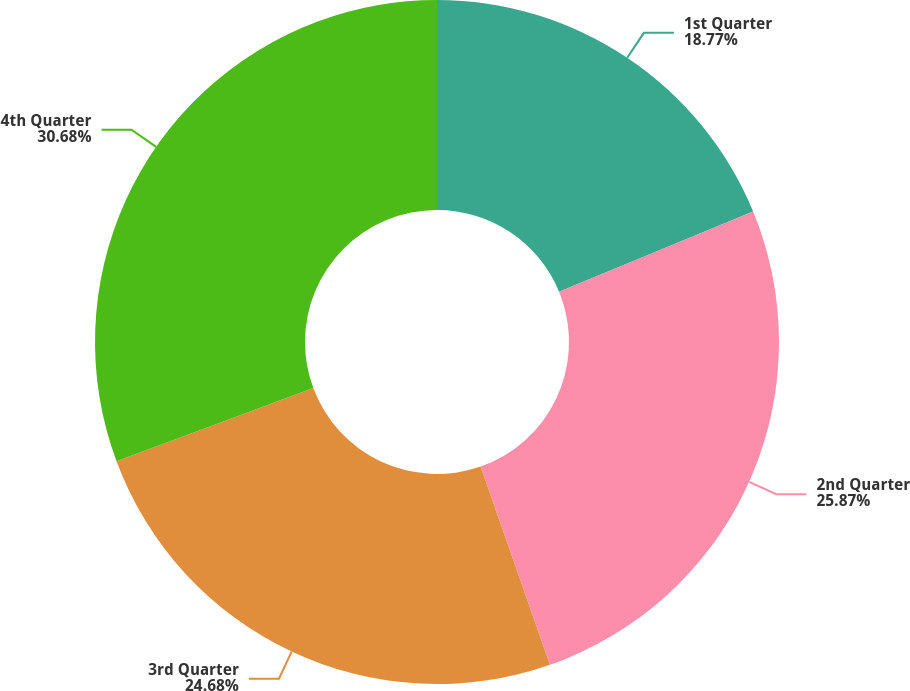Convert chart to OTSL. <chart><loc_0><loc_0><loc_500><loc_500><pie_chart><fcel>1st Quarter<fcel>2nd Quarter<fcel>3rd Quarter<fcel>4th Quarter<nl><fcel>18.77%<fcel>25.87%<fcel>24.68%<fcel>30.67%<nl></chart> 